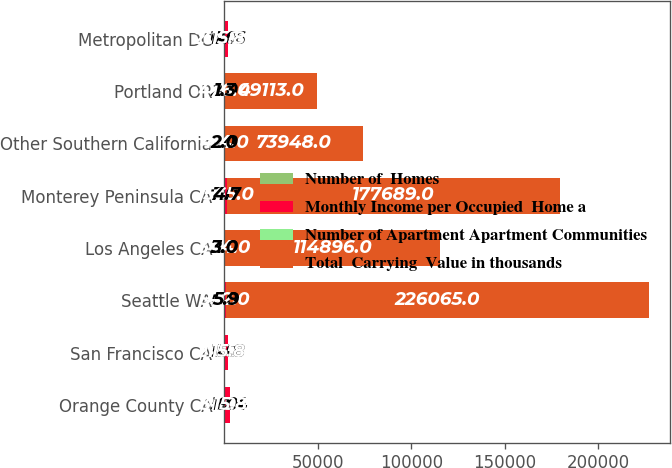<chart> <loc_0><loc_0><loc_500><loc_500><stacked_bar_chart><ecel><fcel>Orange County CA<fcel>San Francisco CA<fcel>Seattle WA<fcel>Los Angeles CA<fcel>Monterey Peninsula CA<fcel>Other Southern California<fcel>Portland OR<fcel>Metropolitan DC<nl><fcel>Number of  Homes<fcel>5<fcel>9<fcel>5<fcel>2<fcel>7<fcel>1<fcel>2<fcel>6<nl><fcel>Monthly Income per Occupied  Home a<fcel>3119<fcel>2185<fcel>932<fcel>344<fcel>1565<fcel>414<fcel>476<fcel>2068<nl><fcel>Number of Apartment Apartment Communities<fcel>19.4<fcel>15.8<fcel>5.9<fcel>3<fcel>4.7<fcel>2<fcel>1.3<fcel>14.6<nl><fcel>Total  Carrying  Value in thousands<fcel>15.8<fcel>15.8<fcel>226065<fcel>114896<fcel>177689<fcel>73948<fcel>49113<fcel>15.8<nl></chart> 